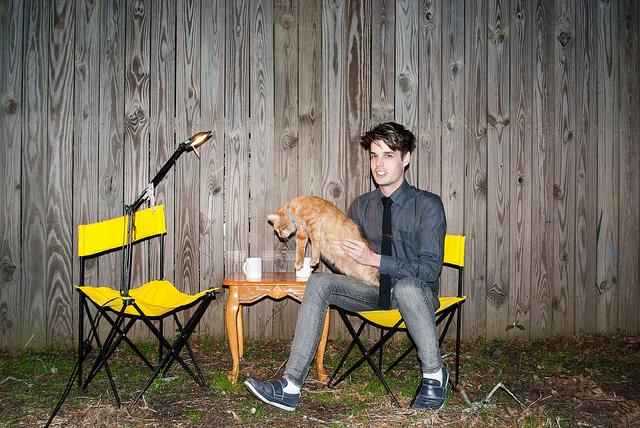Are there more chairs than men?
Be succinct. Yes. Why is there an end table in the grass?
Short answer required. Yes. What animal is the male holding?
Quick response, please. Cat. 